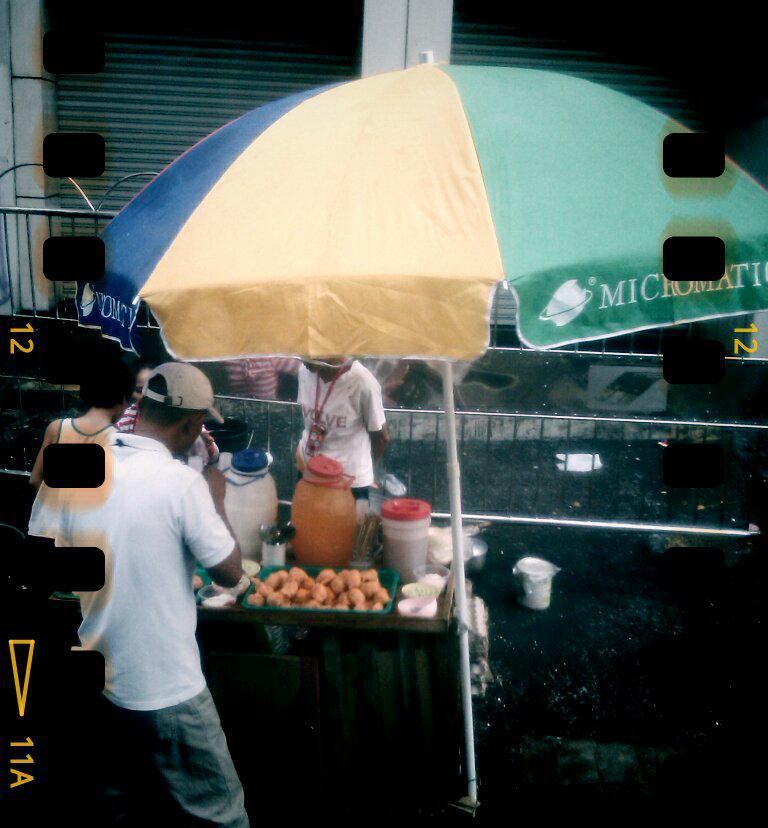Who or what can be seen in the image? There are people in the image. What object is providing shade in the image? There is an umbrella in the image. What is located under the umbrella? There is a table with objects under the umbrella. What can be seen in the distance in the image? There is a building in the background of the image. How many shutters does the building have? The building has two shutters. What type of wash is the mom doing for the beggar in the image? There is no mom, wash, or beggar present in the image. 